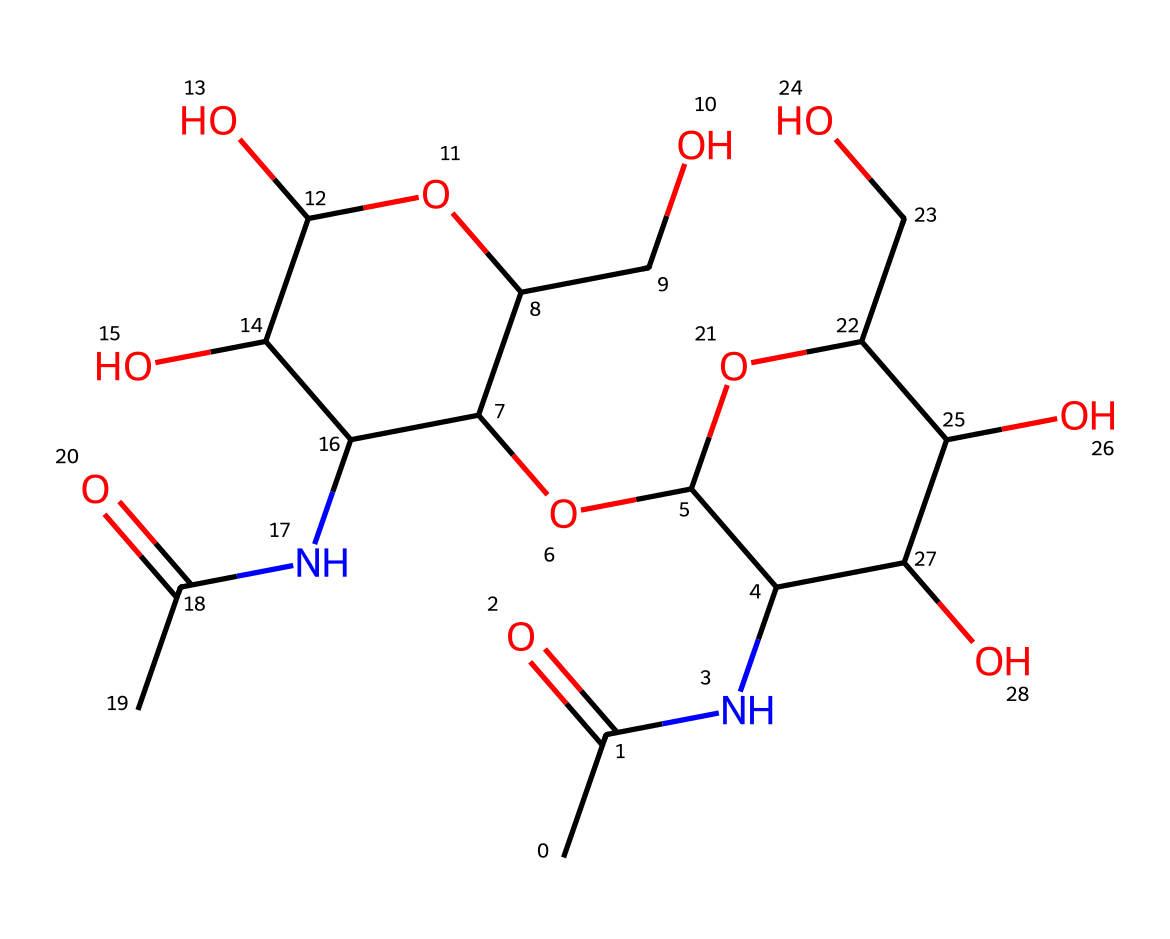What is the primary structural component of chitin? The chemical structure provided indicates that it contains an acetamido group (–NHCOCH3) and multiple hydroxyl groups (–OH), components typically found in chitin, making it a polysaccharide.
Answer: polysaccharide How many rings are present in the structure? The chemical structure shows that there are two cyclic components, indicating the presence of two ring structures within the chitin polymer.
Answer: two What is the degree of substitution for the amino group in this molecule? By inspecting the structure, we can see that there is one acetamido group and it replaces one hydroxyl group in the glucosamine unit, indicating a degree of substitution of one at the amino group in the repeat unit.
Answer: one What is the molecular formula of chitin derived from the SMILES? By analyzing the components in the SMILES representation and counting the various atoms, the molecular formula derived for chitin would be C8H13N1O5.
Answer: C8H13N1O5 How many hydroxyl groups are there in this chemical structure? The structure clearly shows six –OH groups when counting each occurrence in the cyclic units, contributing to the polysaccharide nature of chitin.
Answer: six Which functional groups are prominent in chitin? The provided structure features both acetamido (–NHCOCH3) and multiple hydroxyl (–OH) groups, which are significant functional groups in the chitin molecule.
Answer: acetamido and hydroxyl 